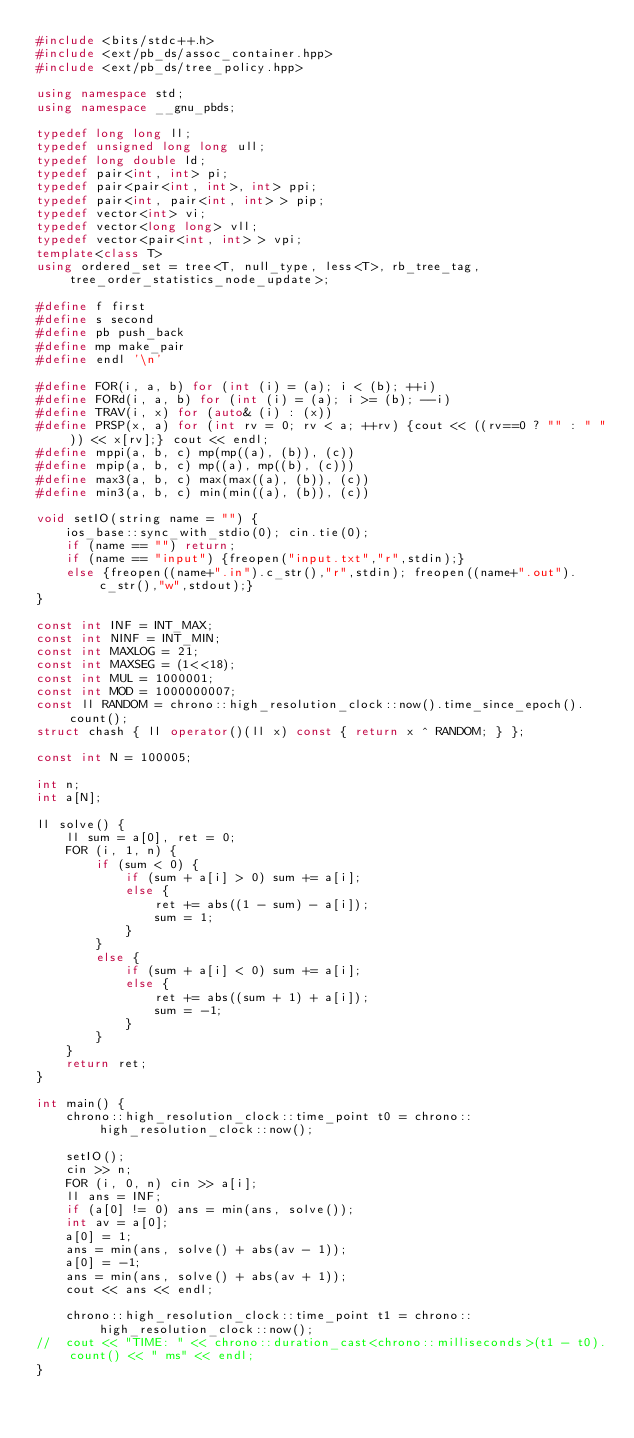Convert code to text. <code><loc_0><loc_0><loc_500><loc_500><_C++_>#include <bits/stdc++.h>
#include <ext/pb_ds/assoc_container.hpp>
#include <ext/pb_ds/tree_policy.hpp>

using namespace std;
using namespace __gnu_pbds;

typedef long long ll;
typedef unsigned long long ull;
typedef long double ld;
typedef pair<int, int> pi;
typedef pair<pair<int, int>, int> ppi;
typedef pair<int, pair<int, int> > pip;
typedef vector<int> vi;
typedef vector<long long> vll;
typedef vector<pair<int, int> > vpi;
template<class T>
using ordered_set = tree<T, null_type, less<T>, rb_tree_tag, tree_order_statistics_node_update>;

#define f first
#define s second
#define pb push_back
#define mp make_pair
#define endl '\n'

#define FOR(i, a, b) for (int (i) = (a); i < (b); ++i)
#define FORd(i, a, b) for (int (i) = (a); i >= (b); --i)
#define TRAV(i, x) for (auto& (i) : (x))
#define PRSP(x, a) for (int rv = 0; rv < a; ++rv) {cout << ((rv==0 ? "" : " ")) << x[rv];} cout << endl;
#define mppi(a, b, c) mp(mp((a), (b)), (c))
#define mpip(a, b, c) mp((a), mp((b), (c)))
#define max3(a, b, c) max(max((a), (b)), (c))
#define min3(a, b, c) min(min((a), (b)), (c))

void setIO(string name = "") {
	ios_base::sync_with_stdio(0); cin.tie(0);
	if (name == "") return;
	if (name == "input") {freopen("input.txt","r",stdin);}
	else {freopen((name+".in").c_str(),"r",stdin); freopen((name+".out").c_str(),"w",stdout);}
}

const int INF = INT_MAX;
const int NINF = INT_MIN;
const int MAXLOG = 21;
const int MAXSEG = (1<<18);
const int MUL = 1000001;
const int MOD = 1000000007;
const ll RANDOM = chrono::high_resolution_clock::now().time_since_epoch().count();
struct chash { ll operator()(ll x) const { return x ^ RANDOM; } };

const int N = 100005;

int n;
int a[N];

ll solve() {
    ll sum = a[0], ret = 0; 
    FOR (i, 1, n) {
        if (sum < 0) {
            if (sum + a[i] > 0) sum += a[i];
            else {
                ret += abs((1 - sum) - a[i]);
                sum = 1;
            }
        }
        else {
            if (sum + a[i] < 0) sum += a[i];
            else {
                ret += abs((sum + 1) + a[i]);
                sum = -1;
            }
        }
    }
    return ret;
}

int main() {
	chrono::high_resolution_clock::time_point t0 = chrono::high_resolution_clock::now();

	setIO();
    cin >> n;
    FOR (i, 0, n) cin >> a[i];
    ll ans = INF;
    if (a[0] != 0) ans = min(ans, solve());
    int av = a[0];
    a[0] = 1;
    ans = min(ans, solve() + abs(av - 1));
    a[0] = -1;
    ans = min(ans, solve() + abs(av + 1));
    cout << ans << endl;

	chrono::high_resolution_clock::time_point t1 = chrono::high_resolution_clock::now();
//	cout << "TIME: " << chrono::duration_cast<chrono::milliseconds>(t1 - t0).count() << " ms" << endl;
}

</code> 